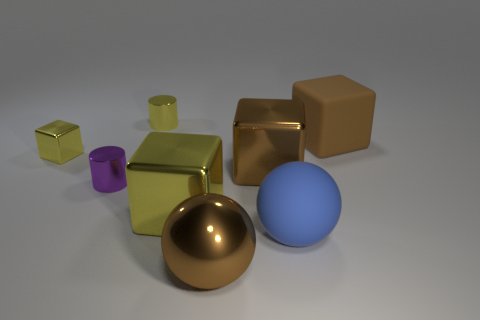Are there more tiny purple things that are in front of the blue object than small blocks?
Make the answer very short. No. How many other things are the same color as the large metallic ball?
Offer a terse response. 2. There is a blue matte thing that is the same size as the metal sphere; what shape is it?
Keep it short and to the point. Sphere. There is a small cylinder that is to the left of the metal cylinder behind the tiny purple thing; what number of big brown metallic balls are on the left side of it?
Provide a succinct answer. 0. What number of shiny things are either yellow cylinders or large brown blocks?
Keep it short and to the point. 2. What color is the metal object that is right of the yellow metallic cylinder and left of the shiny sphere?
Offer a terse response. Yellow. There is a shiny cylinder that is to the right of the purple thing; does it have the same size as the purple cylinder?
Make the answer very short. Yes. How many things are either metallic things to the left of the brown sphere or tiny cyan metallic cylinders?
Your response must be concise. 4. Is there a purple shiny thing of the same size as the yellow cylinder?
Give a very brief answer. Yes. What material is the blue object that is the same size as the metallic sphere?
Offer a very short reply. Rubber. 